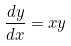<formula> <loc_0><loc_0><loc_500><loc_500>\frac { d y } { d x } = x y</formula> 